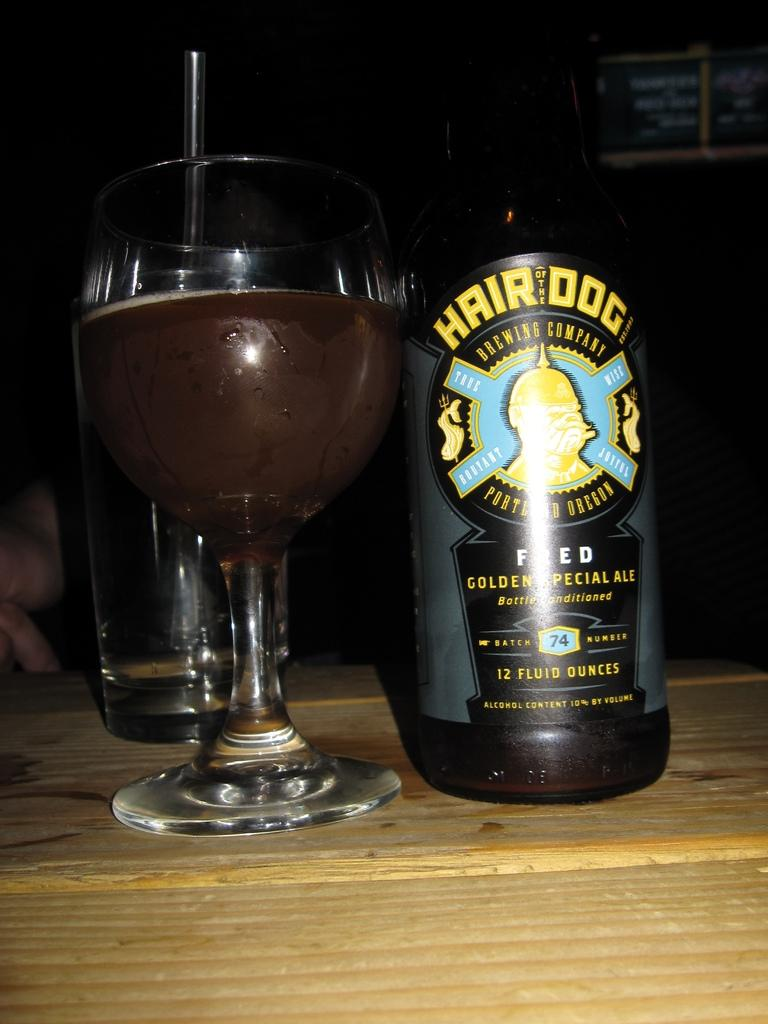<image>
Write a terse but informative summary of the picture. A bottle of Hair of the Dog beer on a table next to a glass. 